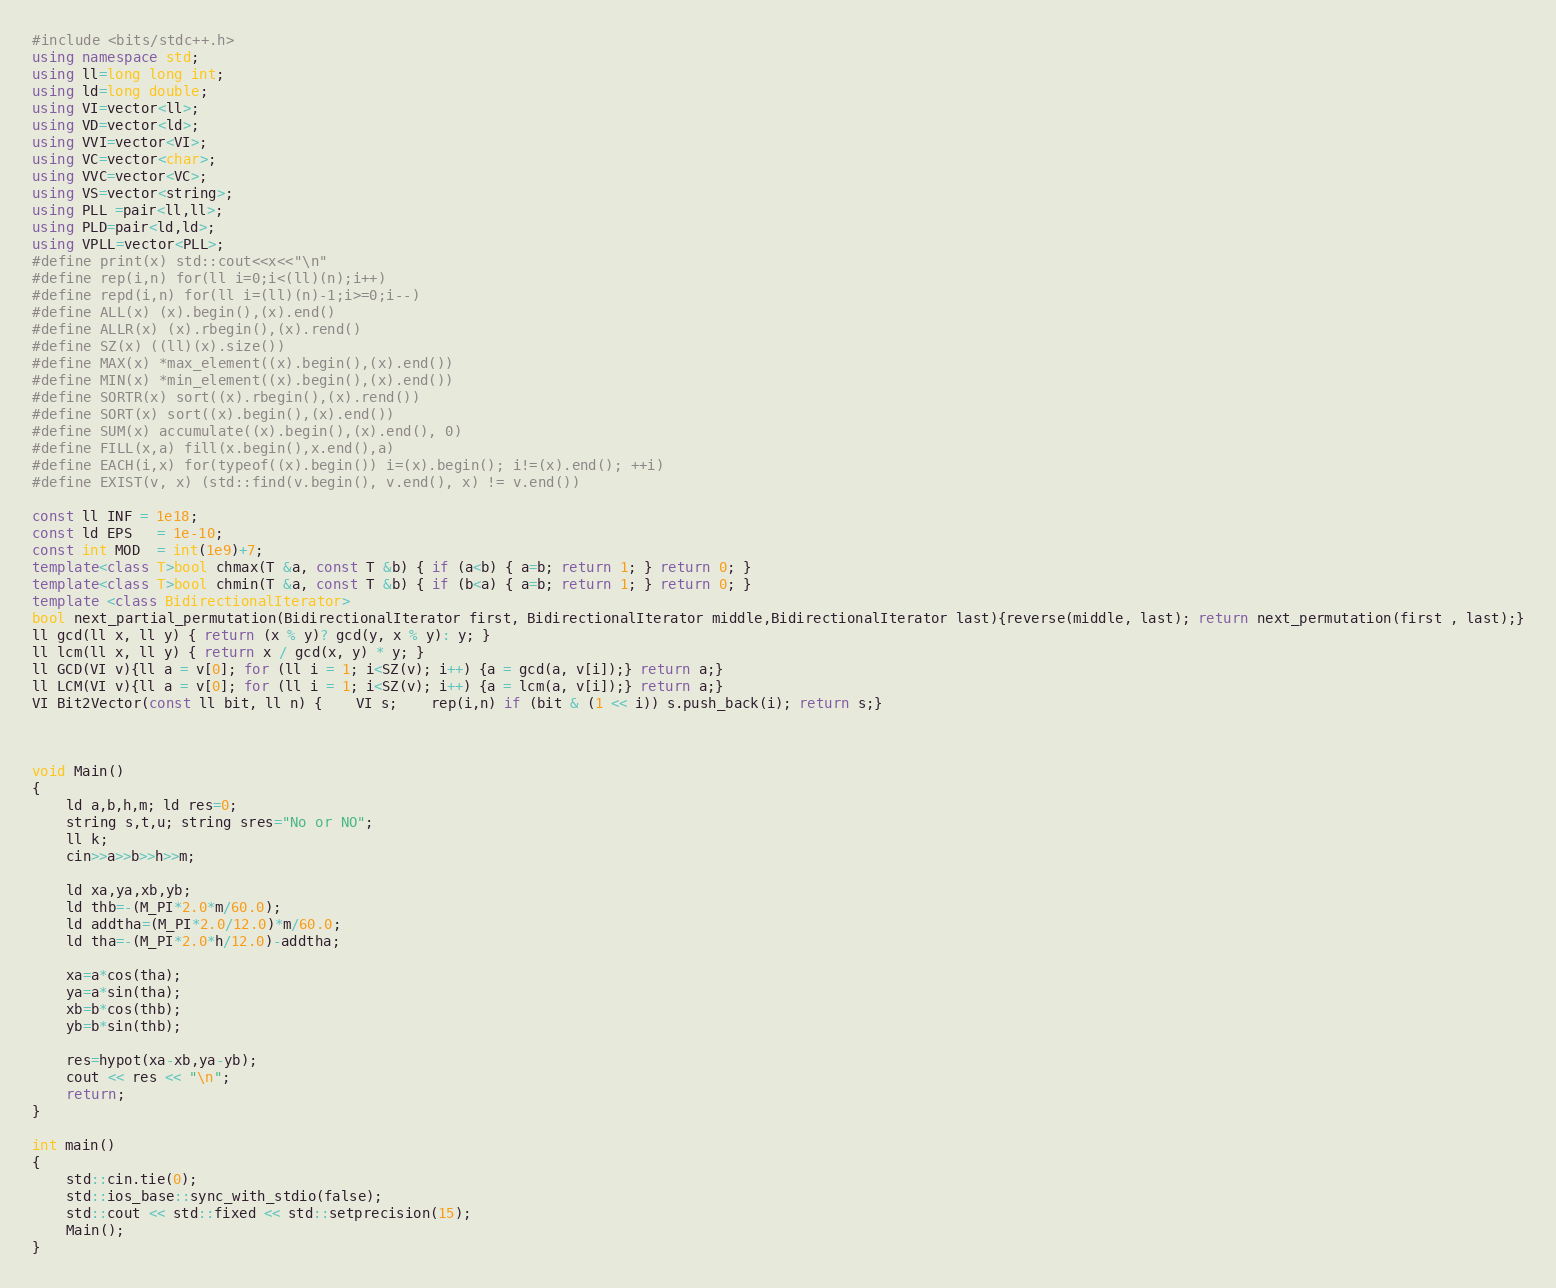<code> <loc_0><loc_0><loc_500><loc_500><_C++_>#include <bits/stdc++.h>
using namespace std;
using ll=long long int;
using ld=long double;
using VI=vector<ll>;
using VD=vector<ld>;
using VVI=vector<VI>;
using VC=vector<char>;
using VVC=vector<VC>;
using VS=vector<string>;
using PLL =pair<ll,ll>;
using PLD=pair<ld,ld>;
using VPLL=vector<PLL>;
#define print(x) std::cout<<x<<"\n"
#define rep(i,n) for(ll i=0;i<(ll)(n);i++)
#define repd(i,n) for(ll i=(ll)(n)-1;i>=0;i--)
#define ALL(x) (x).begin(),(x).end()
#define ALLR(x) (x).rbegin(),(x).rend()
#define SZ(x) ((ll)(x).size())
#define MAX(x) *max_element((x).begin(),(x).end())
#define MIN(x) *min_element((x).begin(),(x).end())
#define SORTR(x) sort((x).rbegin(),(x).rend())
#define SORT(x) sort((x).begin(),(x).end())
#define SUM(x) accumulate((x).begin(),(x).end(), 0)
#define FILL(x,a) fill(x.begin(),x.end(),a)
#define EACH(i,x) for(typeof((x).begin()) i=(x).begin(); i!=(x).end(); ++i)
#define EXIST(v, x) (std::find(v.begin(), v.end(), x) != v.end())

const ll INF = 1e18;
const ld EPS   = 1e-10;
const int MOD  = int(1e9)+7;
template<class T>bool chmax(T &a, const T &b) { if (a<b) { a=b; return 1; } return 0; }
template<class T>bool chmin(T &a, const T &b) { if (b<a) { a=b; return 1; } return 0; }
template <class BidirectionalIterator>
bool next_partial_permutation(BidirectionalIterator first, BidirectionalIterator middle,BidirectionalIterator last){reverse(middle, last); return next_permutation(first , last);}
ll gcd(ll x, ll y) { return (x % y)? gcd(y, x % y): y; }
ll lcm(ll x, ll y) { return x / gcd(x, y) * y; }
ll GCD(VI v){ll a = v[0]; for (ll i = 1; i<SZ(v); i++) {a = gcd(a, v[i]);} return a;}
ll LCM(VI v){ll a = v[0]; for (ll i = 1; i<SZ(v); i++) {a = lcm(a, v[i]);} return a;}
VI Bit2Vector(const ll bit, ll n) {	VI s;	rep(i,n) if (bit & (1 << i)) s.push_back(i); return s;}



void Main()
{
	ld a,b,h,m; ld res=0;
	string s,t,u; string sres="No or NO";
	ll k;
	cin>>a>>b>>h>>m;

	ld xa,ya,xb,yb;
	ld thb=-(M_PI*2.0*m/60.0);
	ld addtha=(M_PI*2.0/12.0)*m/60.0;
	ld tha=-(M_PI*2.0*h/12.0)-addtha;

	xa=a*cos(tha);
	ya=a*sin(tha);
	xb=b*cos(thb);
	yb=b*sin(thb);

	res=hypot(xa-xb,ya-yb);
	cout << res << "\n";
	return;
}

int main()
{
	std::cin.tie(0);
	std::ios_base::sync_with_stdio(false);
	std::cout << std::fixed << std::setprecision(15);
	Main();
}
</code> 